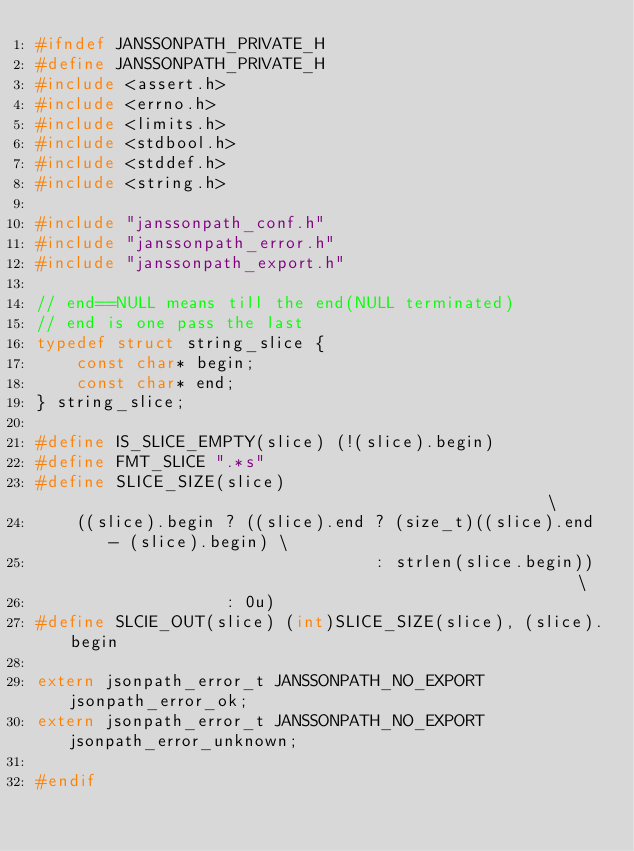<code> <loc_0><loc_0><loc_500><loc_500><_C_>#ifndef JANSSONPATH_PRIVATE_H
#define JANSSONPATH_PRIVATE_H
#include <assert.h>
#include <errno.h>
#include <limits.h>
#include <stdbool.h>
#include <stddef.h>
#include <string.h>

#include "janssonpath_conf.h"
#include "janssonpath_error.h"
#include "janssonpath_export.h"

// end==NULL means till the end(NULL terminated)
// end is one pass the last
typedef struct string_slice {
    const char* begin;
    const char* end;
} string_slice;

#define IS_SLICE_EMPTY(slice) (!(slice).begin)
#define FMT_SLICE ".*s"
#define SLICE_SIZE(slice)                                                 \
    ((slice).begin ? ((slice).end ? (size_t)((slice).end - (slice).begin) \
                                  : strlen(slice.begin))                  \
                   : 0u)
#define SLCIE_OUT(slice) (int)SLICE_SIZE(slice), (slice).begin

extern jsonpath_error_t JANSSONPATH_NO_EXPORT jsonpath_error_ok;
extern jsonpath_error_t JANSSONPATH_NO_EXPORT jsonpath_error_unknown;

#endif
</code> 